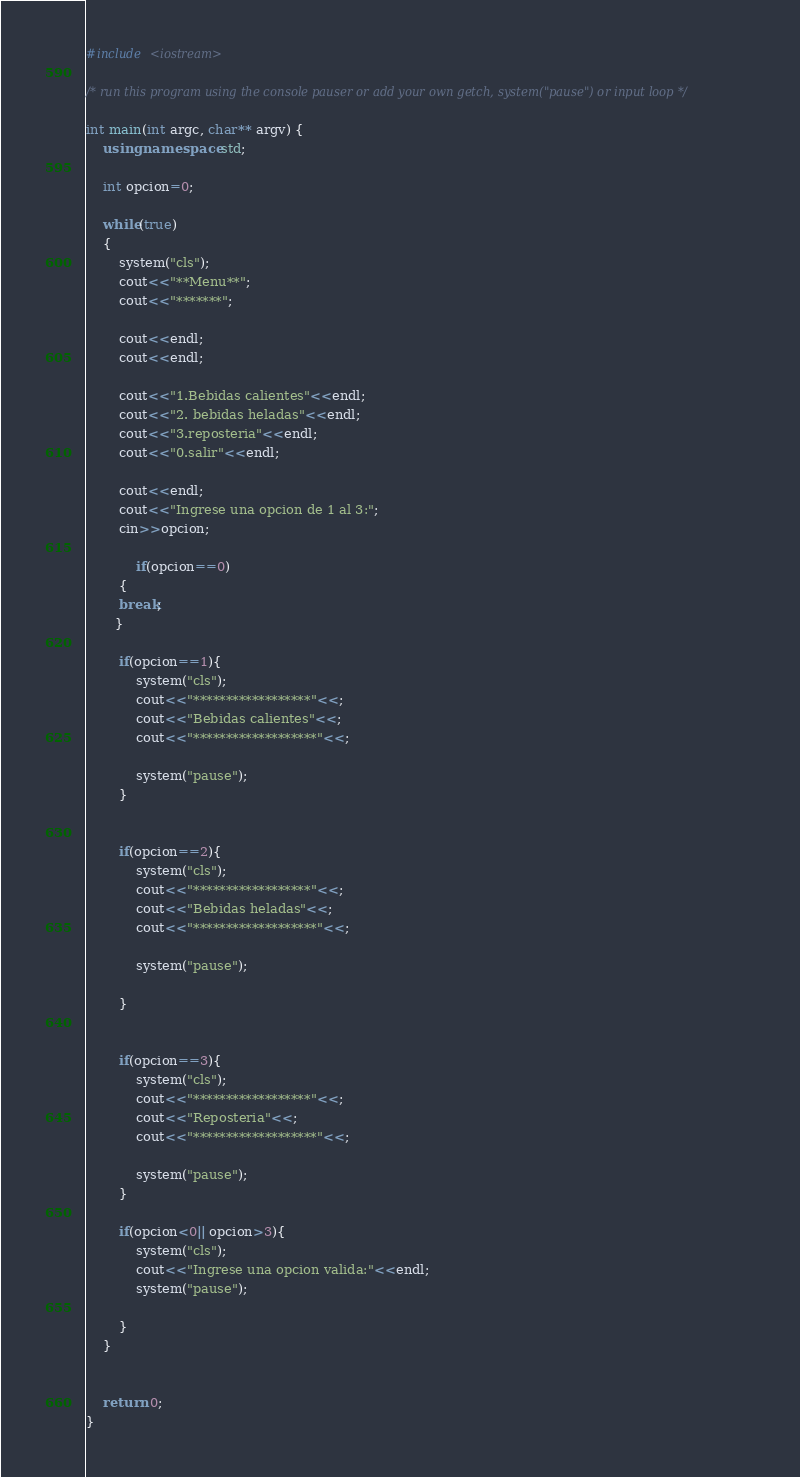<code> <loc_0><loc_0><loc_500><loc_500><_C++_>#include <iostream>

/* run this program using the console pauser or add your own getch, system("pause") or input loop */

int main(int argc, char** argv) {
	using namespace std;
	
	int opcion=0;
	
	while(true)
	{
		system("cls");
		cout<<"**Menu**";
		cout<<"*******";
		
		cout<<endl;
		cout<<endl;
		
		cout<<"1.Bebidas calientes"<<endl;
		cout<<"2. bebidas heladas"<<endl;
		cout<<"3.reposteria"<<endl;
		cout<<"0.salir"<<endl;
		
		cout<<endl;
		cout<<"Ingrese una opcion de 1 al 3:";
		cin>>opcion;
		
			if(opcion==0)
    	{
		break;
	   }
		
		if(opcion==1){
			system("cls");
			cout<<"******************"<<;
			cout<<"Bebidas calientes"<<;
			cout<<"*******************"<<;
			
			system("pause");
		}	
		
		
		if(opcion==2){
			system("cls");
			cout<<"******************"<<;
			cout<<"Bebidas heladas"<<;
			cout<<"*******************"<<;
			
			system("pause");
			
		}	
		
		
		if(opcion==3){
			system("cls");
			cout<<"******************"<<;
			cout<<"Reposteria"<<;
			cout<<"*******************"<<;
			
			system("pause");
		}	
		
		if(opcion<0|| opcion>3){
			system("cls");
			cout<<"Ingrese una opcion valida:"<<endl;
			system("pause");
			
		}
	}
	
	
	return 0;
}
</code> 